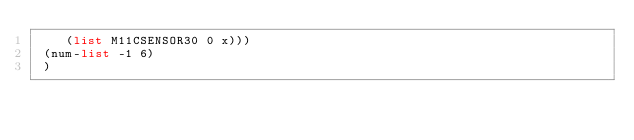Convert code to text. <code><loc_0><loc_0><loc_500><loc_500><_Scheme_>    (list M11CSENSOR30 0 x)))
 (num-list -1 6)
 )

</code> 